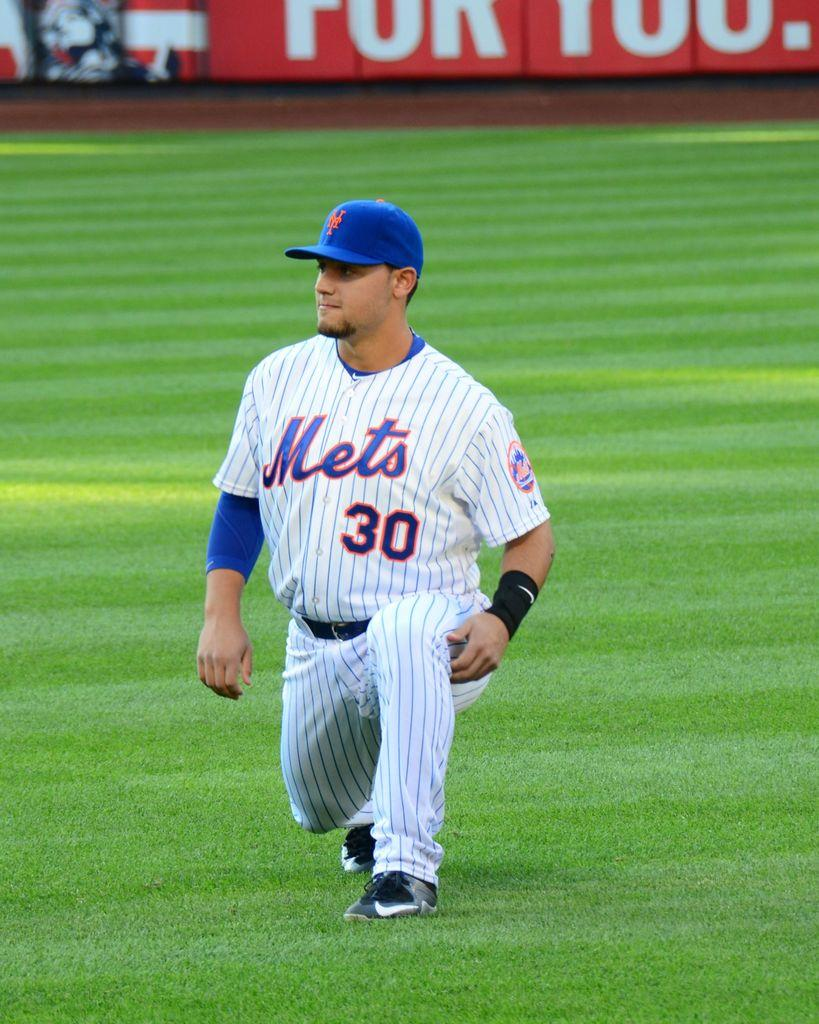<image>
Render a clear and concise summary of the photo. Mets #30 stretches in the outfield on green grass.. 